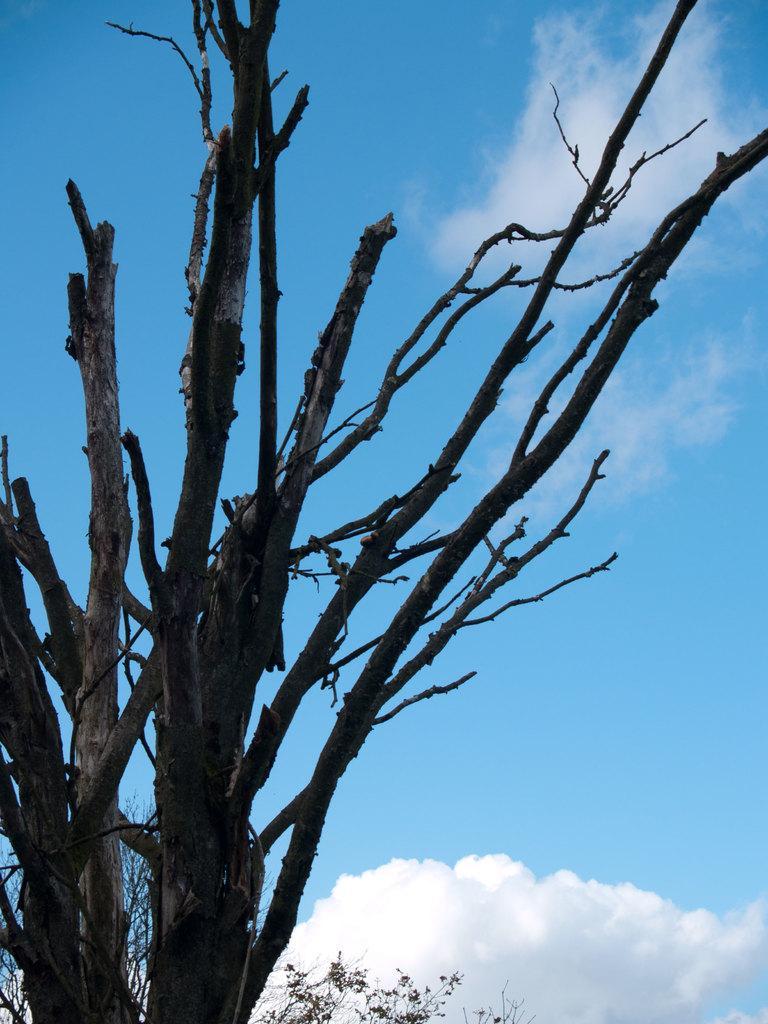In one or two sentences, can you explain what this image depicts? Here in this picture we can see the branches of the tree and we can see clouds in the sky. 